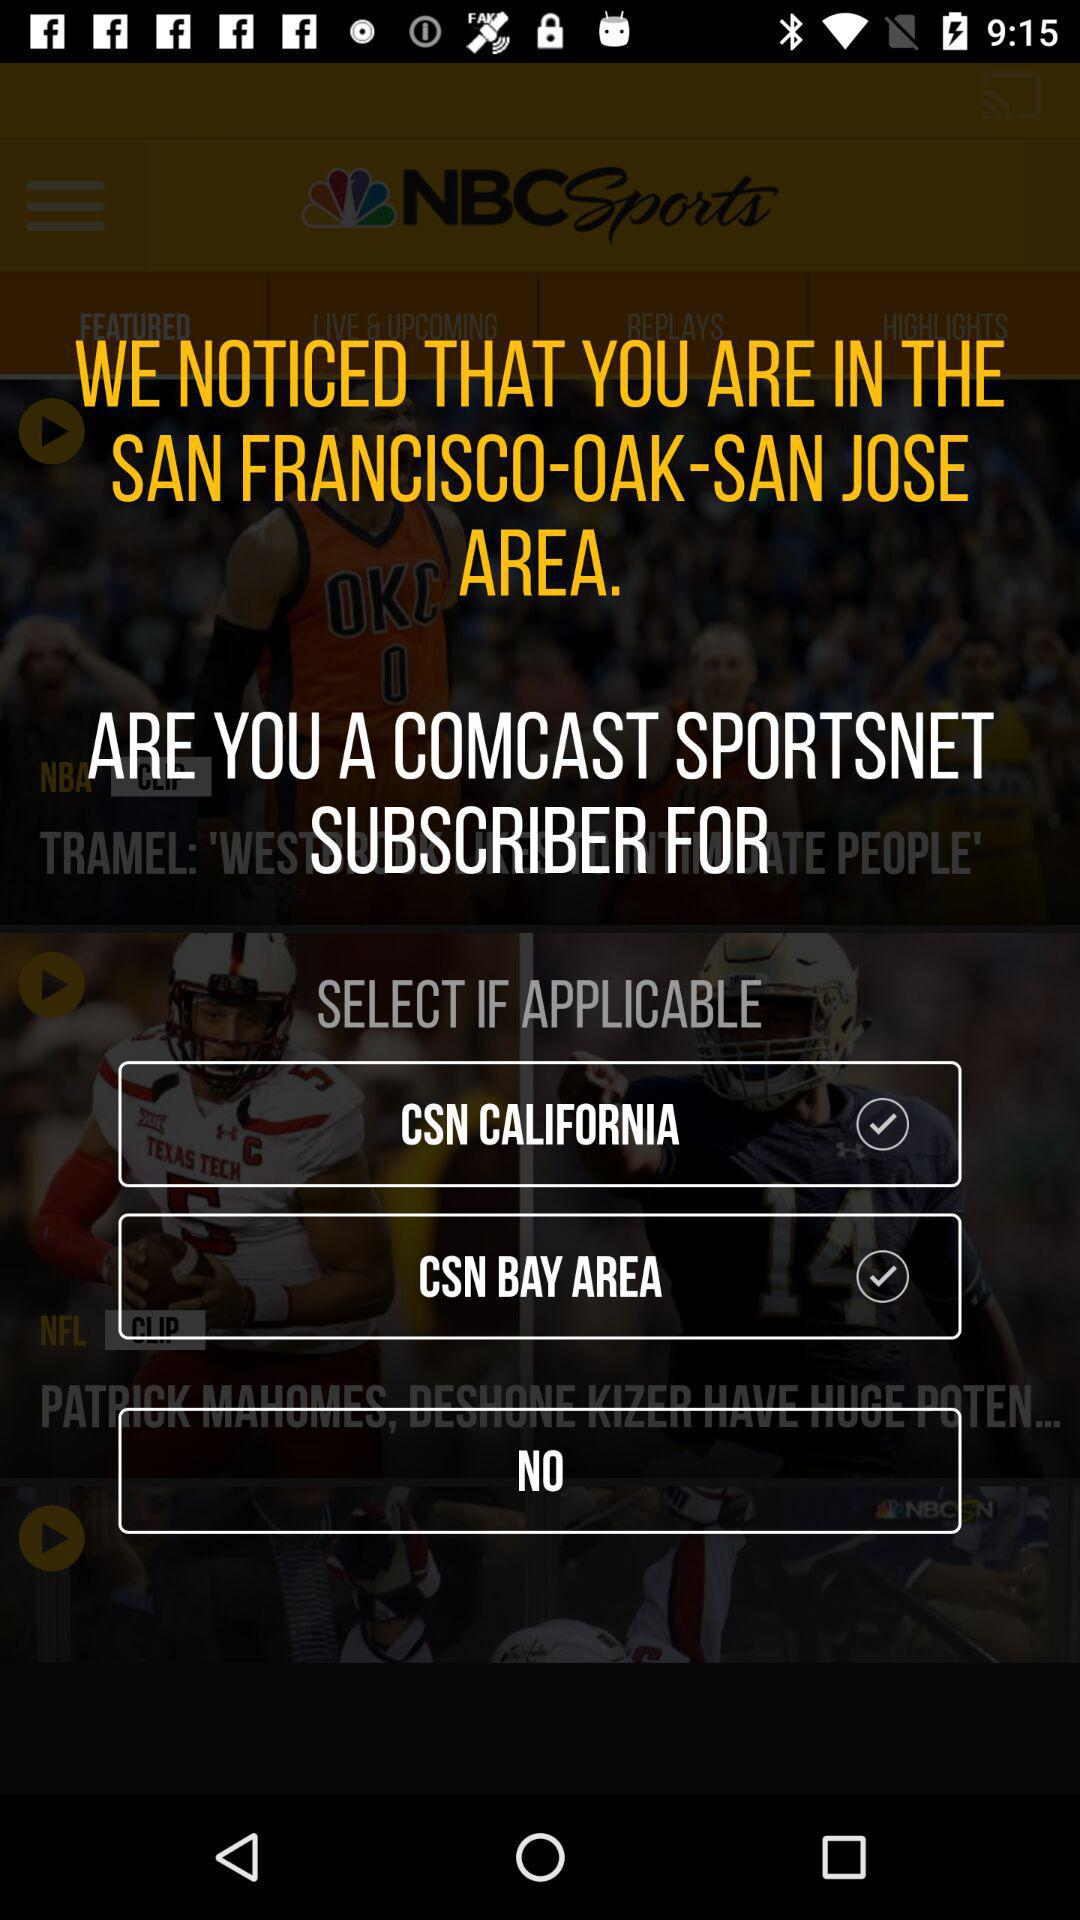What is the location? The location is SAN FRANCISCO-OAK-SAN JOSE. 